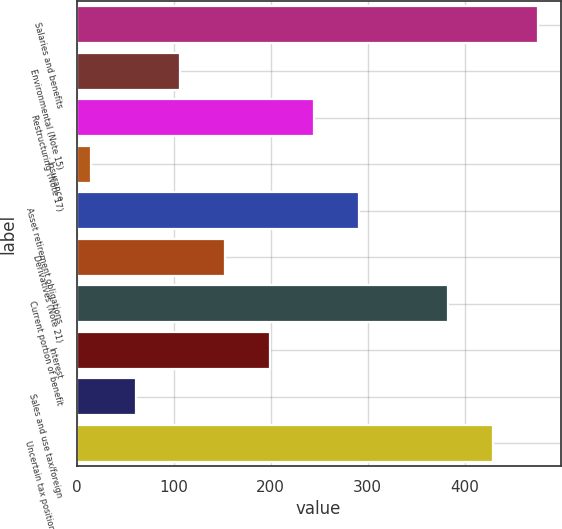<chart> <loc_0><loc_0><loc_500><loc_500><bar_chart><fcel>Salaries and benefits<fcel>Environmental (Note 15)<fcel>Restructuring (Note 17)<fcel>Insurance<fcel>Asset retirement obligations<fcel>Derivatives (Note 21)<fcel>Current portion of benefit<fcel>Interest<fcel>Sales and use tax/foreign<fcel>Uncertain tax positions (Note<nl><fcel>475<fcel>107<fcel>245<fcel>15<fcel>291<fcel>153<fcel>383<fcel>199<fcel>61<fcel>429<nl></chart> 